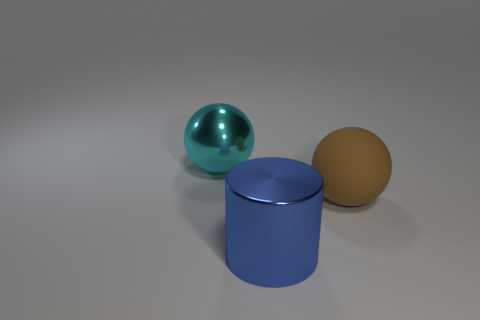What is the large sphere that is on the left side of the ball right of the shiny thing behind the cylinder made of? metal 